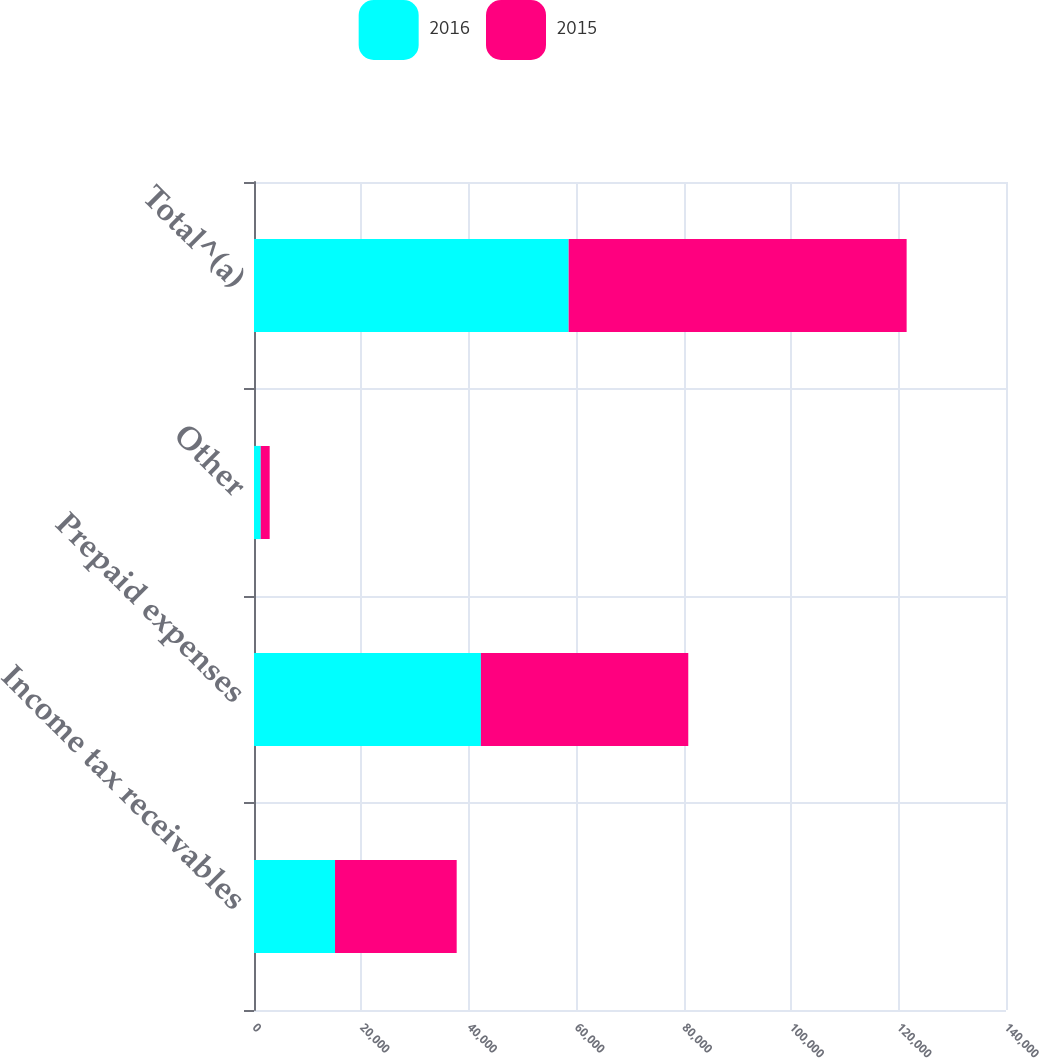<chart> <loc_0><loc_0><loc_500><loc_500><stacked_bar_chart><ecel><fcel>Income tax receivables<fcel>Prepaid expenses<fcel>Other<fcel>Total^(a)<nl><fcel>2016<fcel>15085<fcel>42240<fcel>1254<fcel>58579<nl><fcel>2015<fcel>22649<fcel>38609<fcel>1664<fcel>62922<nl></chart> 